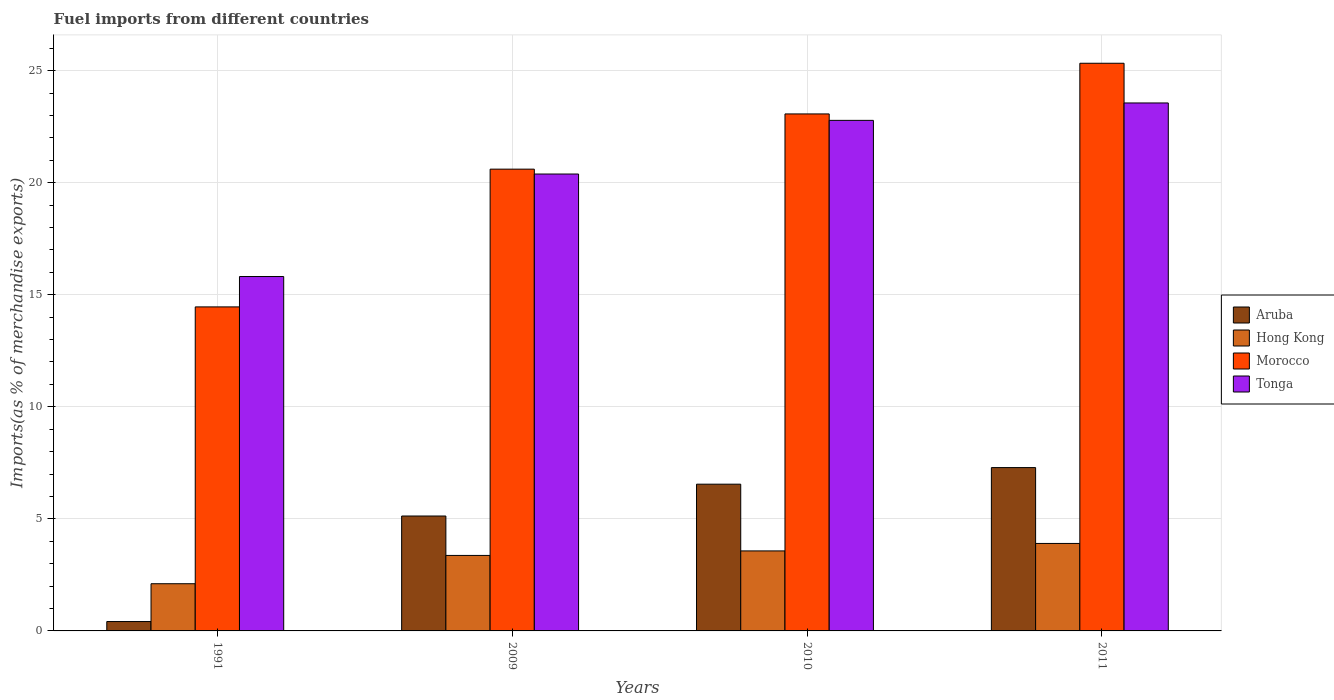Are the number of bars per tick equal to the number of legend labels?
Ensure brevity in your answer.  Yes. In how many cases, is the number of bars for a given year not equal to the number of legend labels?
Make the answer very short. 0. What is the percentage of imports to different countries in Hong Kong in 2011?
Make the answer very short. 3.9. Across all years, what is the maximum percentage of imports to different countries in Tonga?
Keep it short and to the point. 23.56. Across all years, what is the minimum percentage of imports to different countries in Morocco?
Offer a very short reply. 14.46. In which year was the percentage of imports to different countries in Hong Kong minimum?
Provide a short and direct response. 1991. What is the total percentage of imports to different countries in Tonga in the graph?
Your answer should be compact. 82.54. What is the difference between the percentage of imports to different countries in Tonga in 1991 and that in 2011?
Ensure brevity in your answer.  -7.75. What is the difference between the percentage of imports to different countries in Hong Kong in 2011 and the percentage of imports to different countries in Tonga in 1991?
Keep it short and to the point. -11.91. What is the average percentage of imports to different countries in Aruba per year?
Offer a terse response. 4.85. In the year 2009, what is the difference between the percentage of imports to different countries in Hong Kong and percentage of imports to different countries in Tonga?
Offer a terse response. -17.02. What is the ratio of the percentage of imports to different countries in Hong Kong in 2010 to that in 2011?
Provide a succinct answer. 0.91. Is the percentage of imports to different countries in Aruba in 2010 less than that in 2011?
Your answer should be compact. Yes. What is the difference between the highest and the second highest percentage of imports to different countries in Tonga?
Your answer should be very brief. 0.78. What is the difference between the highest and the lowest percentage of imports to different countries in Tonga?
Ensure brevity in your answer.  7.75. In how many years, is the percentage of imports to different countries in Aruba greater than the average percentage of imports to different countries in Aruba taken over all years?
Provide a short and direct response. 3. Is the sum of the percentage of imports to different countries in Morocco in 2010 and 2011 greater than the maximum percentage of imports to different countries in Hong Kong across all years?
Offer a terse response. Yes. Is it the case that in every year, the sum of the percentage of imports to different countries in Tonga and percentage of imports to different countries in Aruba is greater than the sum of percentage of imports to different countries in Hong Kong and percentage of imports to different countries in Morocco?
Give a very brief answer. No. What does the 2nd bar from the left in 2011 represents?
Offer a terse response. Hong Kong. What does the 4th bar from the right in 2011 represents?
Your response must be concise. Aruba. How many bars are there?
Your response must be concise. 16. How many years are there in the graph?
Ensure brevity in your answer.  4. What is the difference between two consecutive major ticks on the Y-axis?
Provide a short and direct response. 5. Are the values on the major ticks of Y-axis written in scientific E-notation?
Give a very brief answer. No. Does the graph contain any zero values?
Make the answer very short. No. How many legend labels are there?
Ensure brevity in your answer.  4. What is the title of the graph?
Offer a very short reply. Fuel imports from different countries. Does "Cote d'Ivoire" appear as one of the legend labels in the graph?
Provide a short and direct response. No. What is the label or title of the Y-axis?
Offer a terse response. Imports(as % of merchandise exports). What is the Imports(as % of merchandise exports) in Aruba in 1991?
Your answer should be very brief. 0.42. What is the Imports(as % of merchandise exports) of Hong Kong in 1991?
Your answer should be very brief. 2.11. What is the Imports(as % of merchandise exports) in Morocco in 1991?
Keep it short and to the point. 14.46. What is the Imports(as % of merchandise exports) in Tonga in 1991?
Provide a short and direct response. 15.81. What is the Imports(as % of merchandise exports) of Aruba in 2009?
Offer a terse response. 5.13. What is the Imports(as % of merchandise exports) of Hong Kong in 2009?
Keep it short and to the point. 3.37. What is the Imports(as % of merchandise exports) of Morocco in 2009?
Give a very brief answer. 20.61. What is the Imports(as % of merchandise exports) of Tonga in 2009?
Make the answer very short. 20.39. What is the Imports(as % of merchandise exports) in Aruba in 2010?
Give a very brief answer. 6.55. What is the Imports(as % of merchandise exports) in Hong Kong in 2010?
Your response must be concise. 3.57. What is the Imports(as % of merchandise exports) in Morocco in 2010?
Ensure brevity in your answer.  23.07. What is the Imports(as % of merchandise exports) in Tonga in 2010?
Ensure brevity in your answer.  22.78. What is the Imports(as % of merchandise exports) in Aruba in 2011?
Your answer should be compact. 7.29. What is the Imports(as % of merchandise exports) in Hong Kong in 2011?
Offer a very short reply. 3.9. What is the Imports(as % of merchandise exports) in Morocco in 2011?
Your answer should be very brief. 25.33. What is the Imports(as % of merchandise exports) in Tonga in 2011?
Provide a succinct answer. 23.56. Across all years, what is the maximum Imports(as % of merchandise exports) of Aruba?
Your answer should be very brief. 7.29. Across all years, what is the maximum Imports(as % of merchandise exports) of Hong Kong?
Provide a short and direct response. 3.9. Across all years, what is the maximum Imports(as % of merchandise exports) in Morocco?
Offer a terse response. 25.33. Across all years, what is the maximum Imports(as % of merchandise exports) in Tonga?
Offer a very short reply. 23.56. Across all years, what is the minimum Imports(as % of merchandise exports) of Aruba?
Offer a terse response. 0.42. Across all years, what is the minimum Imports(as % of merchandise exports) of Hong Kong?
Your response must be concise. 2.11. Across all years, what is the minimum Imports(as % of merchandise exports) in Morocco?
Offer a very short reply. 14.46. Across all years, what is the minimum Imports(as % of merchandise exports) of Tonga?
Your answer should be compact. 15.81. What is the total Imports(as % of merchandise exports) of Aruba in the graph?
Ensure brevity in your answer.  19.38. What is the total Imports(as % of merchandise exports) in Hong Kong in the graph?
Give a very brief answer. 12.95. What is the total Imports(as % of merchandise exports) in Morocco in the graph?
Provide a succinct answer. 83.46. What is the total Imports(as % of merchandise exports) of Tonga in the graph?
Your answer should be very brief. 82.54. What is the difference between the Imports(as % of merchandise exports) of Aruba in 1991 and that in 2009?
Keep it short and to the point. -4.71. What is the difference between the Imports(as % of merchandise exports) of Hong Kong in 1991 and that in 2009?
Offer a terse response. -1.26. What is the difference between the Imports(as % of merchandise exports) in Morocco in 1991 and that in 2009?
Keep it short and to the point. -6.15. What is the difference between the Imports(as % of merchandise exports) in Tonga in 1991 and that in 2009?
Provide a short and direct response. -4.57. What is the difference between the Imports(as % of merchandise exports) in Aruba in 1991 and that in 2010?
Give a very brief answer. -6.13. What is the difference between the Imports(as % of merchandise exports) of Hong Kong in 1991 and that in 2010?
Provide a succinct answer. -1.46. What is the difference between the Imports(as % of merchandise exports) in Morocco in 1991 and that in 2010?
Ensure brevity in your answer.  -8.61. What is the difference between the Imports(as % of merchandise exports) in Tonga in 1991 and that in 2010?
Give a very brief answer. -6.97. What is the difference between the Imports(as % of merchandise exports) in Aruba in 1991 and that in 2011?
Keep it short and to the point. -6.87. What is the difference between the Imports(as % of merchandise exports) in Hong Kong in 1991 and that in 2011?
Provide a succinct answer. -1.8. What is the difference between the Imports(as % of merchandise exports) of Morocco in 1991 and that in 2011?
Your answer should be very brief. -10.87. What is the difference between the Imports(as % of merchandise exports) in Tonga in 1991 and that in 2011?
Ensure brevity in your answer.  -7.75. What is the difference between the Imports(as % of merchandise exports) in Aruba in 2009 and that in 2010?
Make the answer very short. -1.42. What is the difference between the Imports(as % of merchandise exports) in Hong Kong in 2009 and that in 2010?
Offer a very short reply. -0.2. What is the difference between the Imports(as % of merchandise exports) in Morocco in 2009 and that in 2010?
Your answer should be very brief. -2.46. What is the difference between the Imports(as % of merchandise exports) in Tonga in 2009 and that in 2010?
Ensure brevity in your answer.  -2.39. What is the difference between the Imports(as % of merchandise exports) of Aruba in 2009 and that in 2011?
Offer a very short reply. -2.16. What is the difference between the Imports(as % of merchandise exports) in Hong Kong in 2009 and that in 2011?
Offer a terse response. -0.54. What is the difference between the Imports(as % of merchandise exports) of Morocco in 2009 and that in 2011?
Give a very brief answer. -4.72. What is the difference between the Imports(as % of merchandise exports) in Tonga in 2009 and that in 2011?
Give a very brief answer. -3.17. What is the difference between the Imports(as % of merchandise exports) in Aruba in 2010 and that in 2011?
Make the answer very short. -0.74. What is the difference between the Imports(as % of merchandise exports) of Hong Kong in 2010 and that in 2011?
Keep it short and to the point. -0.33. What is the difference between the Imports(as % of merchandise exports) of Morocco in 2010 and that in 2011?
Offer a terse response. -2.26. What is the difference between the Imports(as % of merchandise exports) of Tonga in 2010 and that in 2011?
Give a very brief answer. -0.78. What is the difference between the Imports(as % of merchandise exports) in Aruba in 1991 and the Imports(as % of merchandise exports) in Hong Kong in 2009?
Provide a succinct answer. -2.95. What is the difference between the Imports(as % of merchandise exports) in Aruba in 1991 and the Imports(as % of merchandise exports) in Morocco in 2009?
Provide a short and direct response. -20.19. What is the difference between the Imports(as % of merchandise exports) of Aruba in 1991 and the Imports(as % of merchandise exports) of Tonga in 2009?
Provide a succinct answer. -19.97. What is the difference between the Imports(as % of merchandise exports) of Hong Kong in 1991 and the Imports(as % of merchandise exports) of Morocco in 2009?
Provide a succinct answer. -18.5. What is the difference between the Imports(as % of merchandise exports) in Hong Kong in 1991 and the Imports(as % of merchandise exports) in Tonga in 2009?
Make the answer very short. -18.28. What is the difference between the Imports(as % of merchandise exports) in Morocco in 1991 and the Imports(as % of merchandise exports) in Tonga in 2009?
Make the answer very short. -5.93. What is the difference between the Imports(as % of merchandise exports) of Aruba in 1991 and the Imports(as % of merchandise exports) of Hong Kong in 2010?
Your answer should be compact. -3.15. What is the difference between the Imports(as % of merchandise exports) in Aruba in 1991 and the Imports(as % of merchandise exports) in Morocco in 2010?
Make the answer very short. -22.65. What is the difference between the Imports(as % of merchandise exports) in Aruba in 1991 and the Imports(as % of merchandise exports) in Tonga in 2010?
Ensure brevity in your answer.  -22.36. What is the difference between the Imports(as % of merchandise exports) of Hong Kong in 1991 and the Imports(as % of merchandise exports) of Morocco in 2010?
Offer a very short reply. -20.96. What is the difference between the Imports(as % of merchandise exports) in Hong Kong in 1991 and the Imports(as % of merchandise exports) in Tonga in 2010?
Your response must be concise. -20.68. What is the difference between the Imports(as % of merchandise exports) in Morocco in 1991 and the Imports(as % of merchandise exports) in Tonga in 2010?
Provide a succinct answer. -8.32. What is the difference between the Imports(as % of merchandise exports) of Aruba in 1991 and the Imports(as % of merchandise exports) of Hong Kong in 2011?
Your answer should be compact. -3.48. What is the difference between the Imports(as % of merchandise exports) in Aruba in 1991 and the Imports(as % of merchandise exports) in Morocco in 2011?
Provide a succinct answer. -24.91. What is the difference between the Imports(as % of merchandise exports) of Aruba in 1991 and the Imports(as % of merchandise exports) of Tonga in 2011?
Make the answer very short. -23.14. What is the difference between the Imports(as % of merchandise exports) in Hong Kong in 1991 and the Imports(as % of merchandise exports) in Morocco in 2011?
Ensure brevity in your answer.  -23.22. What is the difference between the Imports(as % of merchandise exports) in Hong Kong in 1991 and the Imports(as % of merchandise exports) in Tonga in 2011?
Your answer should be compact. -21.45. What is the difference between the Imports(as % of merchandise exports) of Morocco in 1991 and the Imports(as % of merchandise exports) of Tonga in 2011?
Your answer should be very brief. -9.1. What is the difference between the Imports(as % of merchandise exports) of Aruba in 2009 and the Imports(as % of merchandise exports) of Hong Kong in 2010?
Provide a short and direct response. 1.56. What is the difference between the Imports(as % of merchandise exports) in Aruba in 2009 and the Imports(as % of merchandise exports) in Morocco in 2010?
Make the answer very short. -17.94. What is the difference between the Imports(as % of merchandise exports) of Aruba in 2009 and the Imports(as % of merchandise exports) of Tonga in 2010?
Offer a terse response. -17.65. What is the difference between the Imports(as % of merchandise exports) in Hong Kong in 2009 and the Imports(as % of merchandise exports) in Morocco in 2010?
Provide a short and direct response. -19.7. What is the difference between the Imports(as % of merchandise exports) of Hong Kong in 2009 and the Imports(as % of merchandise exports) of Tonga in 2010?
Provide a short and direct response. -19.41. What is the difference between the Imports(as % of merchandise exports) of Morocco in 2009 and the Imports(as % of merchandise exports) of Tonga in 2010?
Offer a terse response. -2.18. What is the difference between the Imports(as % of merchandise exports) in Aruba in 2009 and the Imports(as % of merchandise exports) in Hong Kong in 2011?
Offer a very short reply. 1.22. What is the difference between the Imports(as % of merchandise exports) of Aruba in 2009 and the Imports(as % of merchandise exports) of Morocco in 2011?
Your answer should be very brief. -20.2. What is the difference between the Imports(as % of merchandise exports) of Aruba in 2009 and the Imports(as % of merchandise exports) of Tonga in 2011?
Your answer should be very brief. -18.43. What is the difference between the Imports(as % of merchandise exports) in Hong Kong in 2009 and the Imports(as % of merchandise exports) in Morocco in 2011?
Provide a succinct answer. -21.96. What is the difference between the Imports(as % of merchandise exports) of Hong Kong in 2009 and the Imports(as % of merchandise exports) of Tonga in 2011?
Keep it short and to the point. -20.19. What is the difference between the Imports(as % of merchandise exports) of Morocco in 2009 and the Imports(as % of merchandise exports) of Tonga in 2011?
Your answer should be very brief. -2.95. What is the difference between the Imports(as % of merchandise exports) of Aruba in 2010 and the Imports(as % of merchandise exports) of Hong Kong in 2011?
Provide a succinct answer. 2.64. What is the difference between the Imports(as % of merchandise exports) of Aruba in 2010 and the Imports(as % of merchandise exports) of Morocco in 2011?
Your answer should be compact. -18.78. What is the difference between the Imports(as % of merchandise exports) of Aruba in 2010 and the Imports(as % of merchandise exports) of Tonga in 2011?
Give a very brief answer. -17.01. What is the difference between the Imports(as % of merchandise exports) of Hong Kong in 2010 and the Imports(as % of merchandise exports) of Morocco in 2011?
Keep it short and to the point. -21.76. What is the difference between the Imports(as % of merchandise exports) in Hong Kong in 2010 and the Imports(as % of merchandise exports) in Tonga in 2011?
Your answer should be very brief. -19.99. What is the difference between the Imports(as % of merchandise exports) in Morocco in 2010 and the Imports(as % of merchandise exports) in Tonga in 2011?
Provide a short and direct response. -0.49. What is the average Imports(as % of merchandise exports) of Aruba per year?
Your response must be concise. 4.85. What is the average Imports(as % of merchandise exports) of Hong Kong per year?
Your answer should be compact. 3.24. What is the average Imports(as % of merchandise exports) in Morocco per year?
Give a very brief answer. 20.87. What is the average Imports(as % of merchandise exports) in Tonga per year?
Your answer should be very brief. 20.64. In the year 1991, what is the difference between the Imports(as % of merchandise exports) in Aruba and Imports(as % of merchandise exports) in Hong Kong?
Ensure brevity in your answer.  -1.69. In the year 1991, what is the difference between the Imports(as % of merchandise exports) of Aruba and Imports(as % of merchandise exports) of Morocco?
Make the answer very short. -14.04. In the year 1991, what is the difference between the Imports(as % of merchandise exports) of Aruba and Imports(as % of merchandise exports) of Tonga?
Ensure brevity in your answer.  -15.39. In the year 1991, what is the difference between the Imports(as % of merchandise exports) in Hong Kong and Imports(as % of merchandise exports) in Morocco?
Ensure brevity in your answer.  -12.35. In the year 1991, what is the difference between the Imports(as % of merchandise exports) of Hong Kong and Imports(as % of merchandise exports) of Tonga?
Your answer should be compact. -13.71. In the year 1991, what is the difference between the Imports(as % of merchandise exports) in Morocco and Imports(as % of merchandise exports) in Tonga?
Your response must be concise. -1.36. In the year 2009, what is the difference between the Imports(as % of merchandise exports) of Aruba and Imports(as % of merchandise exports) of Hong Kong?
Give a very brief answer. 1.76. In the year 2009, what is the difference between the Imports(as % of merchandise exports) in Aruba and Imports(as % of merchandise exports) in Morocco?
Your answer should be very brief. -15.48. In the year 2009, what is the difference between the Imports(as % of merchandise exports) of Aruba and Imports(as % of merchandise exports) of Tonga?
Provide a succinct answer. -15.26. In the year 2009, what is the difference between the Imports(as % of merchandise exports) of Hong Kong and Imports(as % of merchandise exports) of Morocco?
Offer a very short reply. -17.24. In the year 2009, what is the difference between the Imports(as % of merchandise exports) in Hong Kong and Imports(as % of merchandise exports) in Tonga?
Offer a very short reply. -17.02. In the year 2009, what is the difference between the Imports(as % of merchandise exports) of Morocco and Imports(as % of merchandise exports) of Tonga?
Make the answer very short. 0.22. In the year 2010, what is the difference between the Imports(as % of merchandise exports) in Aruba and Imports(as % of merchandise exports) in Hong Kong?
Provide a short and direct response. 2.98. In the year 2010, what is the difference between the Imports(as % of merchandise exports) in Aruba and Imports(as % of merchandise exports) in Morocco?
Provide a short and direct response. -16.52. In the year 2010, what is the difference between the Imports(as % of merchandise exports) of Aruba and Imports(as % of merchandise exports) of Tonga?
Give a very brief answer. -16.23. In the year 2010, what is the difference between the Imports(as % of merchandise exports) in Hong Kong and Imports(as % of merchandise exports) in Morocco?
Make the answer very short. -19.5. In the year 2010, what is the difference between the Imports(as % of merchandise exports) of Hong Kong and Imports(as % of merchandise exports) of Tonga?
Provide a succinct answer. -19.21. In the year 2010, what is the difference between the Imports(as % of merchandise exports) in Morocco and Imports(as % of merchandise exports) in Tonga?
Your answer should be very brief. 0.29. In the year 2011, what is the difference between the Imports(as % of merchandise exports) in Aruba and Imports(as % of merchandise exports) in Hong Kong?
Ensure brevity in your answer.  3.38. In the year 2011, what is the difference between the Imports(as % of merchandise exports) of Aruba and Imports(as % of merchandise exports) of Morocco?
Give a very brief answer. -18.04. In the year 2011, what is the difference between the Imports(as % of merchandise exports) of Aruba and Imports(as % of merchandise exports) of Tonga?
Provide a succinct answer. -16.27. In the year 2011, what is the difference between the Imports(as % of merchandise exports) of Hong Kong and Imports(as % of merchandise exports) of Morocco?
Your response must be concise. -21.43. In the year 2011, what is the difference between the Imports(as % of merchandise exports) of Hong Kong and Imports(as % of merchandise exports) of Tonga?
Provide a succinct answer. -19.66. In the year 2011, what is the difference between the Imports(as % of merchandise exports) of Morocco and Imports(as % of merchandise exports) of Tonga?
Ensure brevity in your answer.  1.77. What is the ratio of the Imports(as % of merchandise exports) of Aruba in 1991 to that in 2009?
Make the answer very short. 0.08. What is the ratio of the Imports(as % of merchandise exports) in Hong Kong in 1991 to that in 2009?
Ensure brevity in your answer.  0.63. What is the ratio of the Imports(as % of merchandise exports) of Morocco in 1991 to that in 2009?
Your answer should be compact. 0.7. What is the ratio of the Imports(as % of merchandise exports) in Tonga in 1991 to that in 2009?
Provide a short and direct response. 0.78. What is the ratio of the Imports(as % of merchandise exports) in Aruba in 1991 to that in 2010?
Your answer should be very brief. 0.06. What is the ratio of the Imports(as % of merchandise exports) in Hong Kong in 1991 to that in 2010?
Your response must be concise. 0.59. What is the ratio of the Imports(as % of merchandise exports) in Morocco in 1991 to that in 2010?
Provide a succinct answer. 0.63. What is the ratio of the Imports(as % of merchandise exports) in Tonga in 1991 to that in 2010?
Provide a succinct answer. 0.69. What is the ratio of the Imports(as % of merchandise exports) in Aruba in 1991 to that in 2011?
Ensure brevity in your answer.  0.06. What is the ratio of the Imports(as % of merchandise exports) in Hong Kong in 1991 to that in 2011?
Keep it short and to the point. 0.54. What is the ratio of the Imports(as % of merchandise exports) in Morocco in 1991 to that in 2011?
Offer a very short reply. 0.57. What is the ratio of the Imports(as % of merchandise exports) of Tonga in 1991 to that in 2011?
Your answer should be compact. 0.67. What is the ratio of the Imports(as % of merchandise exports) in Aruba in 2009 to that in 2010?
Provide a succinct answer. 0.78. What is the ratio of the Imports(as % of merchandise exports) in Hong Kong in 2009 to that in 2010?
Offer a terse response. 0.94. What is the ratio of the Imports(as % of merchandise exports) of Morocco in 2009 to that in 2010?
Provide a succinct answer. 0.89. What is the ratio of the Imports(as % of merchandise exports) in Tonga in 2009 to that in 2010?
Provide a succinct answer. 0.89. What is the ratio of the Imports(as % of merchandise exports) of Aruba in 2009 to that in 2011?
Your answer should be compact. 0.7. What is the ratio of the Imports(as % of merchandise exports) in Hong Kong in 2009 to that in 2011?
Make the answer very short. 0.86. What is the ratio of the Imports(as % of merchandise exports) of Morocco in 2009 to that in 2011?
Ensure brevity in your answer.  0.81. What is the ratio of the Imports(as % of merchandise exports) of Tonga in 2009 to that in 2011?
Provide a succinct answer. 0.87. What is the ratio of the Imports(as % of merchandise exports) of Aruba in 2010 to that in 2011?
Ensure brevity in your answer.  0.9. What is the ratio of the Imports(as % of merchandise exports) of Hong Kong in 2010 to that in 2011?
Provide a succinct answer. 0.91. What is the ratio of the Imports(as % of merchandise exports) in Morocco in 2010 to that in 2011?
Offer a terse response. 0.91. What is the ratio of the Imports(as % of merchandise exports) in Tonga in 2010 to that in 2011?
Your response must be concise. 0.97. What is the difference between the highest and the second highest Imports(as % of merchandise exports) in Aruba?
Your answer should be compact. 0.74. What is the difference between the highest and the second highest Imports(as % of merchandise exports) in Hong Kong?
Provide a short and direct response. 0.33. What is the difference between the highest and the second highest Imports(as % of merchandise exports) in Morocco?
Give a very brief answer. 2.26. What is the difference between the highest and the second highest Imports(as % of merchandise exports) of Tonga?
Provide a succinct answer. 0.78. What is the difference between the highest and the lowest Imports(as % of merchandise exports) of Aruba?
Make the answer very short. 6.87. What is the difference between the highest and the lowest Imports(as % of merchandise exports) of Hong Kong?
Your response must be concise. 1.8. What is the difference between the highest and the lowest Imports(as % of merchandise exports) in Morocco?
Give a very brief answer. 10.87. What is the difference between the highest and the lowest Imports(as % of merchandise exports) in Tonga?
Keep it short and to the point. 7.75. 